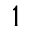Convert formula to latex. <formula><loc_0><loc_0><loc_500><loc_500>^ { 1 }</formula> 